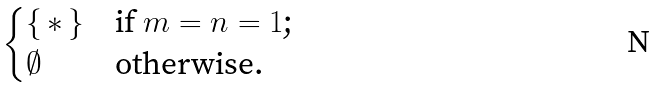Convert formula to latex. <formula><loc_0><loc_0><loc_500><loc_500>\begin{cases} \{ \, \ast \, \} & \text {if $m = n = 1$;} \\ \emptyset & \text {otherwise.} \end{cases}</formula> 